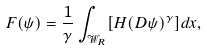<formula> <loc_0><loc_0><loc_500><loc_500>F ( \psi ) = \frac { 1 } { \gamma } \int _ { \mathcal { W } _ { R } } [ H ( D \psi ) ^ { \gamma } ] d x ,</formula> 